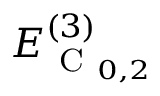Convert formula to latex. <formula><loc_0><loc_0><loc_500><loc_500>E _ { C _ { 0 , 2 } } ^ { ( 3 ) }</formula> 